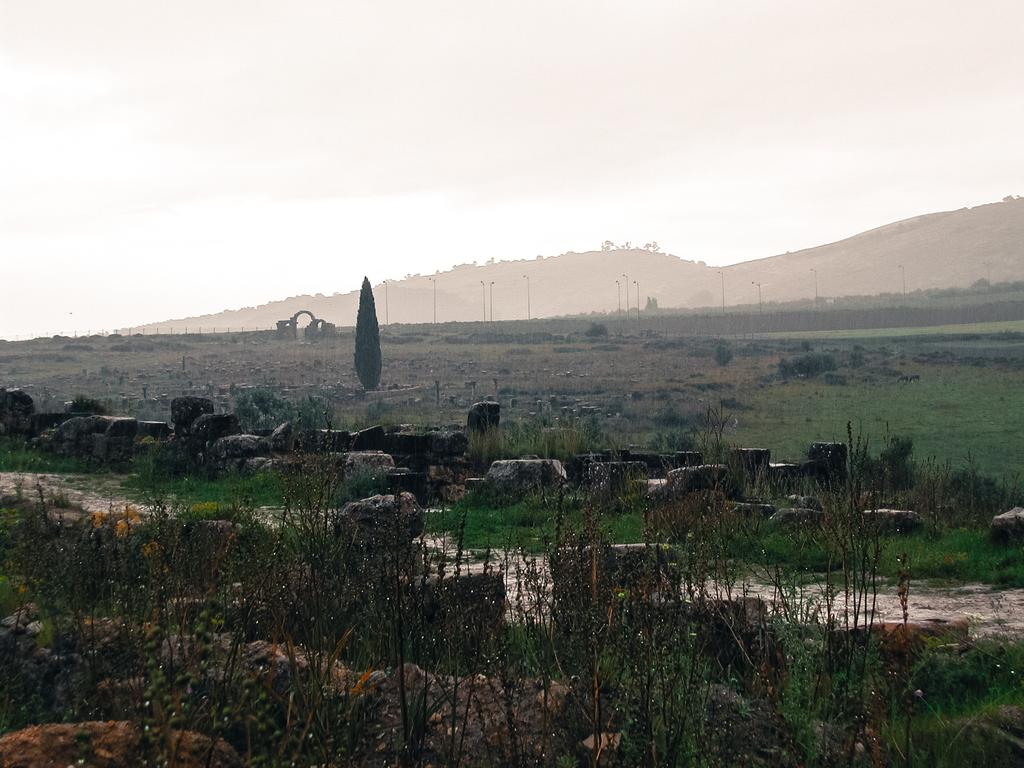What type of vegetation can be seen in the image? There are plants and trees in the image. What other natural elements are present in the image? There are rocks in the image. What can be seen in the background of the image? There are mountains in the background of the image. What is the condition of the sky in the image? The sky is clear in the image. Where is the nearest downtown area in the image? There is no downtown area present in the image, as it features natural elements such as plants, rocks, trees, mountains, and a clear sky. 